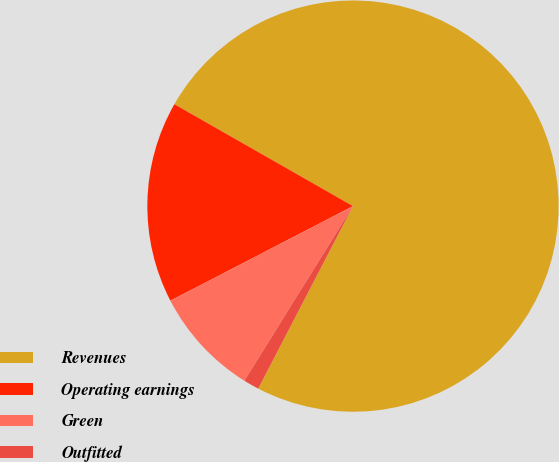Convert chart. <chart><loc_0><loc_0><loc_500><loc_500><pie_chart><fcel>Revenues<fcel>Operating earnings<fcel>Green<fcel>Outfitted<nl><fcel>74.37%<fcel>15.86%<fcel>8.54%<fcel>1.23%<nl></chart> 